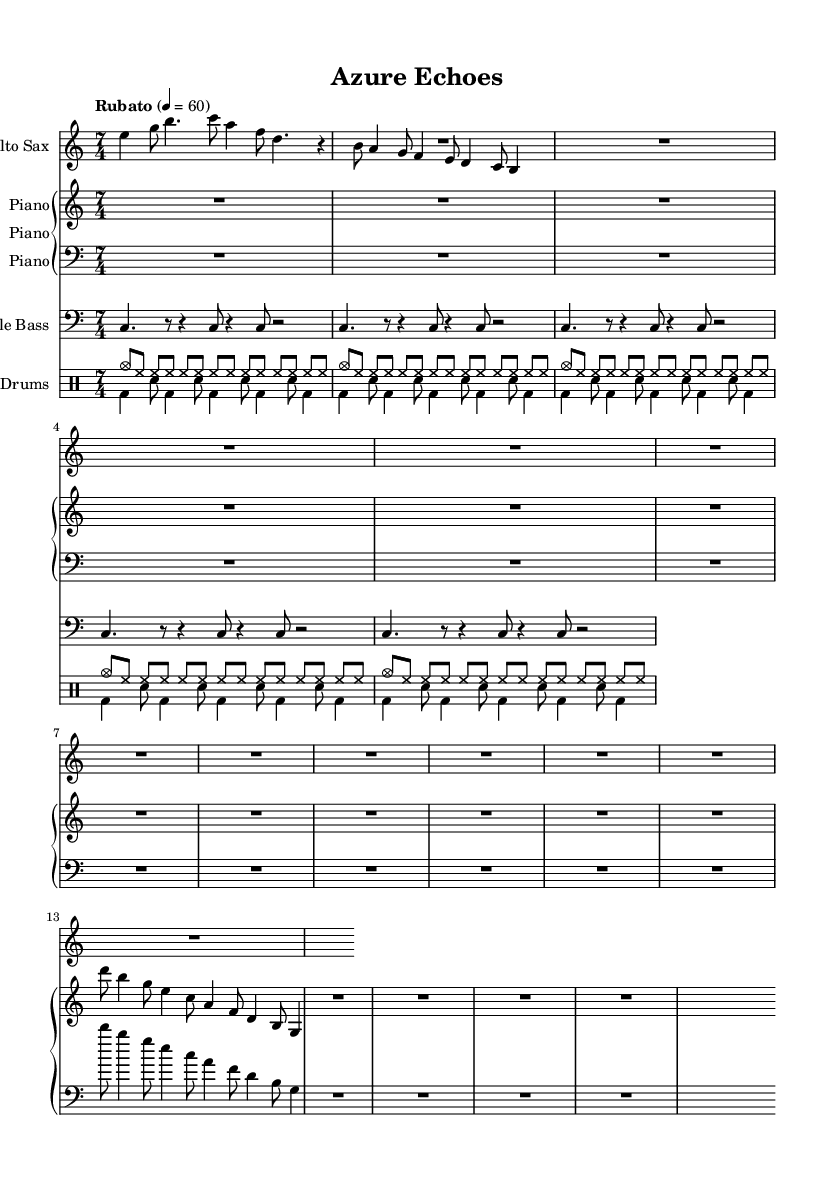What is the time signature of this music? The time signature is indicated at the beginning of the sheet music as 7/4, which means there are seven beats in each measure, and the quarter note gets one beat.
Answer: 7/4 What is the tempo marking of this piece? The tempo marking is shown as "Rubato" with a tempo indication of 60 quarter notes per minute, suggesting a flexible tempo approach typical in jazz music.
Answer: Rubato, 60 What instrument plays the introduction? The introduction is played by the Alto Saxophone, as indicated by the notation after the instrument name at the beginning of the respective staff.
Answer: Alto Sax How many measures are there in the "Improvisation" section? The "Improvisation" section is marked with a whole rest for the Alto Sax, which spans seven beats (since the time signature is 7/4), indicating one measure of silence. Additionally, both the Piano and Drums also have extended measures during this section. Thus, it is one measure in total.
Answer: 1 What musical form is primarily employed in this piece? The piece features clearly defined themes A and B, with placeholders for improvisation, emphasizing the call-and-response and formal structure typical in jazz compositions. This combination of themes and improvisation characteristics points to a traditional AABA form structure.
Answer: AABA What type of rhythmic pattern does the Double Bass use? The Double Bass part shows a syncopated rhythmic pattern throughout the sheet music, utilizing various rests and sustained notes which create a rhythmic drive while maintaining the overall structure of the piece.
Answer: Syncopated How many times is the coda played? The Coda section is marked to be played once following the themes and improvisation when indicated, consistent with jazz performances which often repeat sections as interpreted by the ensemble.
Answer: 1 